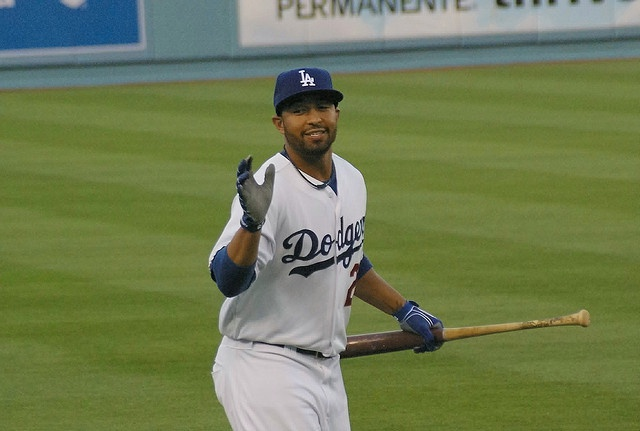Describe the objects in this image and their specific colors. I can see people in darkgray, lightgray, black, and gray tones and baseball bat in darkgray, black, tan, olive, and gray tones in this image. 